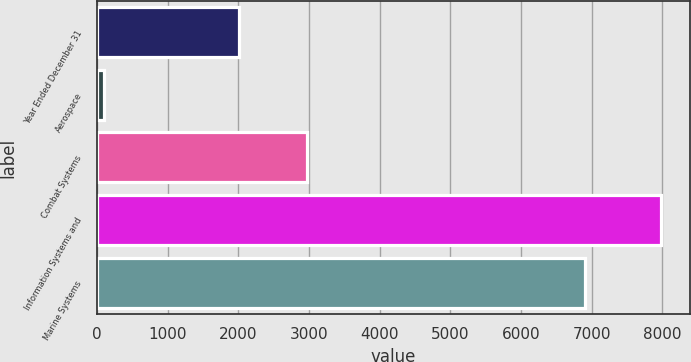Convert chart. <chart><loc_0><loc_0><loc_500><loc_500><bar_chart><fcel>Year Ended December 31<fcel>Aerospace<fcel>Combat Systems<fcel>Information Systems and<fcel>Marine Systems<nl><fcel>2014<fcel>99<fcel>2970<fcel>7985<fcel>6901<nl></chart> 